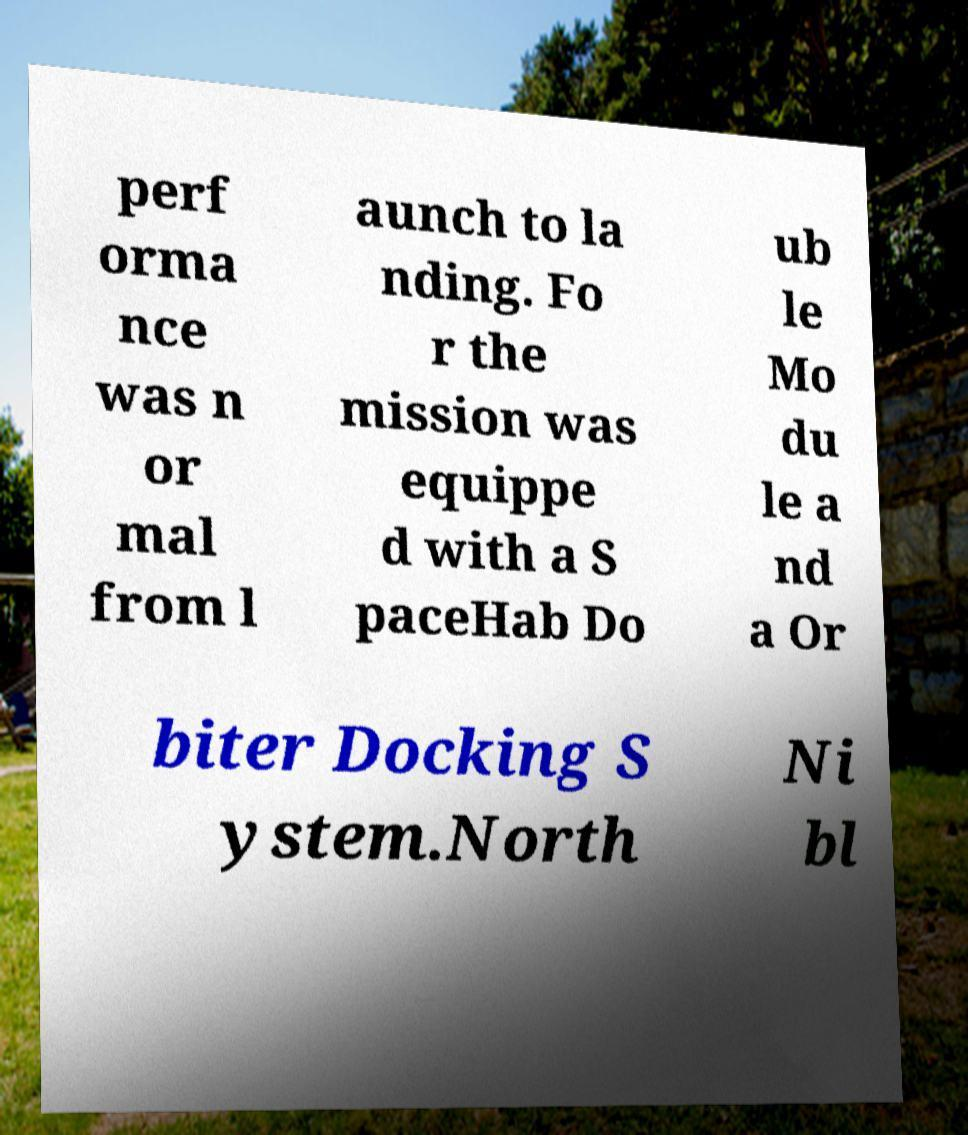Could you extract and type out the text from this image? perf orma nce was n or mal from l aunch to la nding. Fo r the mission was equippe d with a S paceHab Do ub le Mo du le a nd a Or biter Docking S ystem.North Ni bl 